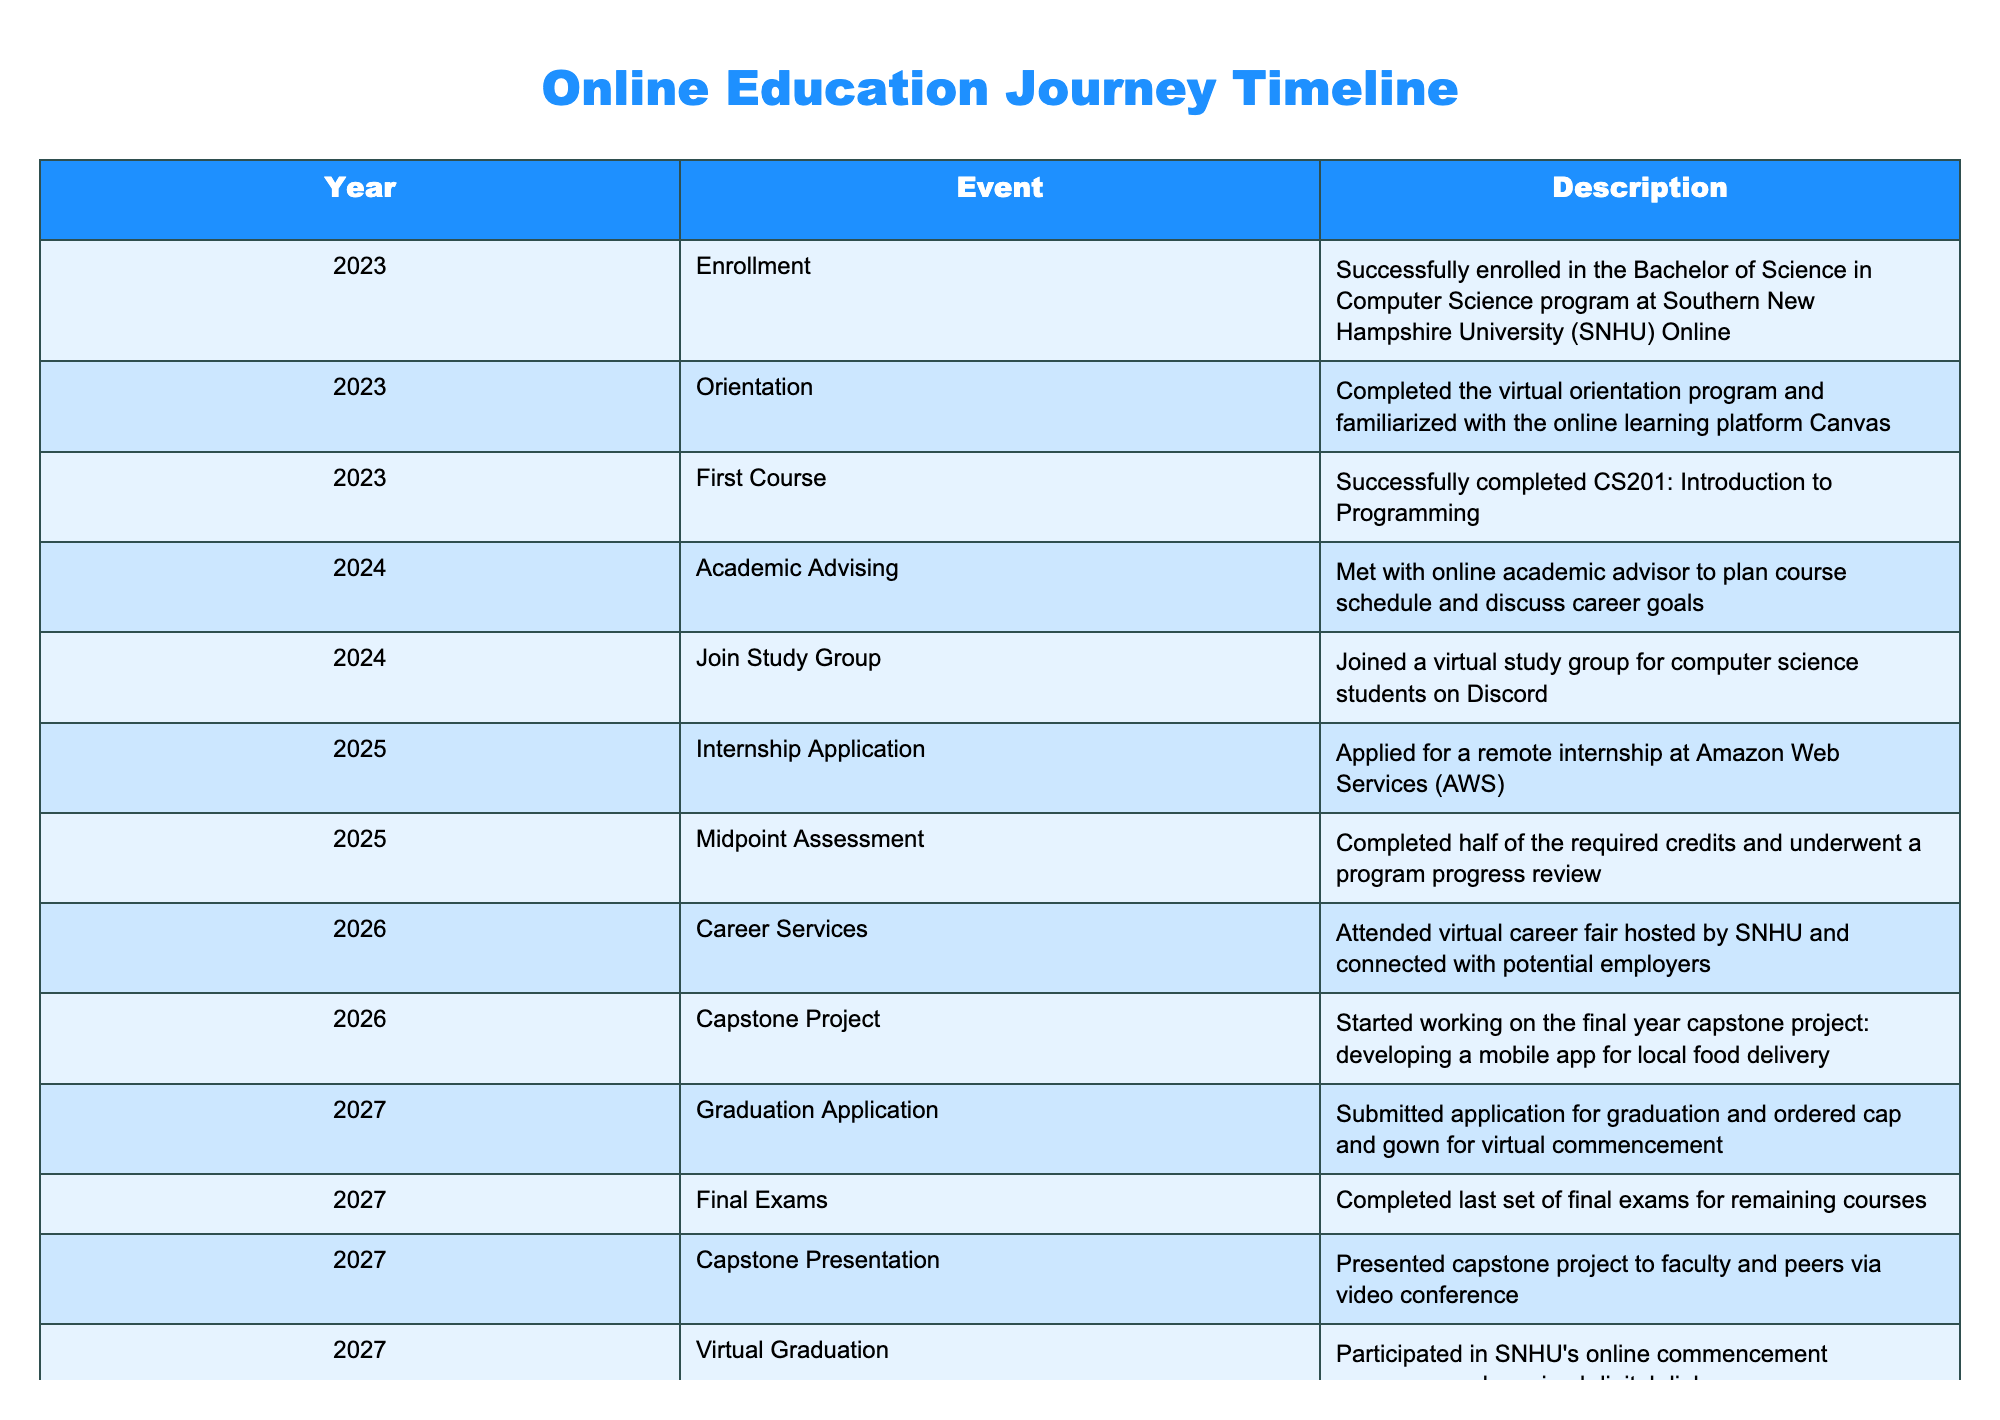What year did the student first enroll in the program? The table lists the year under the "Enrollment" event, which is specified as 2023.
Answer: 2023 How many significant events occurred between enrollment and graduation? By counting the events listed from "Enrollment" in 2023 to "Virtual Graduation" in 2027, there are 10 events described.
Answer: 10 Was the student able to join a study group? The table indicates that the student joined a virtual study group on Discord in 2024.
Answer: Yes What is the time gap between submitting the graduation application and the virtual graduation? The graduation application was submitted in 2027, and the virtual graduation occurred in the same year. Thus, the time gap is less than a year, effectively zero months or days.
Answer: 0 Which event occurred last before graduation? The last event listed before graduation is the completion of the "Final Exams," which occurred in 2027. This indicates that the last academic requirement was fulfilled right before graduation.
Answer: Final Exams How many years passed from enrollment to graduation? The enrollment took place in 2023, and the graduation occurred in 2027. Thus, the duration is 2027 - 2023 = 4 years.
Answer: 4 years Did the student have any interaction with career services before graduating? Yes, according to the table, the student attended a virtual career fair in 2026, indicating contact with career services.
Answer: Yes What was the focus of the student's capstone project? The capstone project described in the table was focused on developing a mobile app for local food delivery, indicating its application in a specific industry sector.
Answer: Mobile app for local food delivery In which year did the student complete the midpoint assessment? The table shows that the midpoint assessment was completed in 2025, which is two years after enrollment and shows progress in the program.
Answer: 2025 